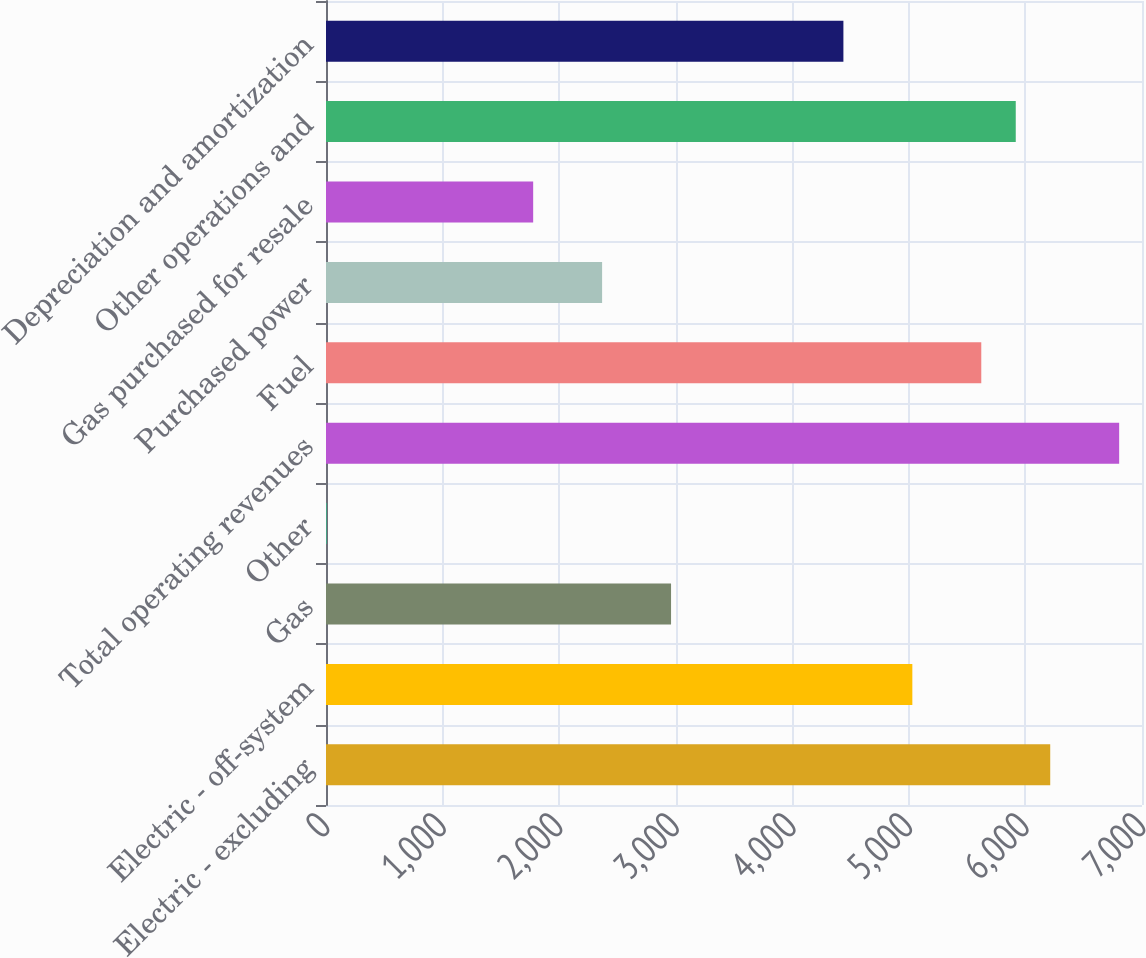Convert chart to OTSL. <chart><loc_0><loc_0><loc_500><loc_500><bar_chart><fcel>Electric - excluding<fcel>Electric - off-system<fcel>Gas<fcel>Other<fcel>Total operating revenues<fcel>Fuel<fcel>Purchased power<fcel>Gas purchased for resale<fcel>Other operations and<fcel>Depreciation and amortization<nl><fcel>6212.7<fcel>5029.9<fcel>2960<fcel>3<fcel>6804.1<fcel>5621.3<fcel>2368.6<fcel>1777.2<fcel>5917<fcel>4438.5<nl></chart> 